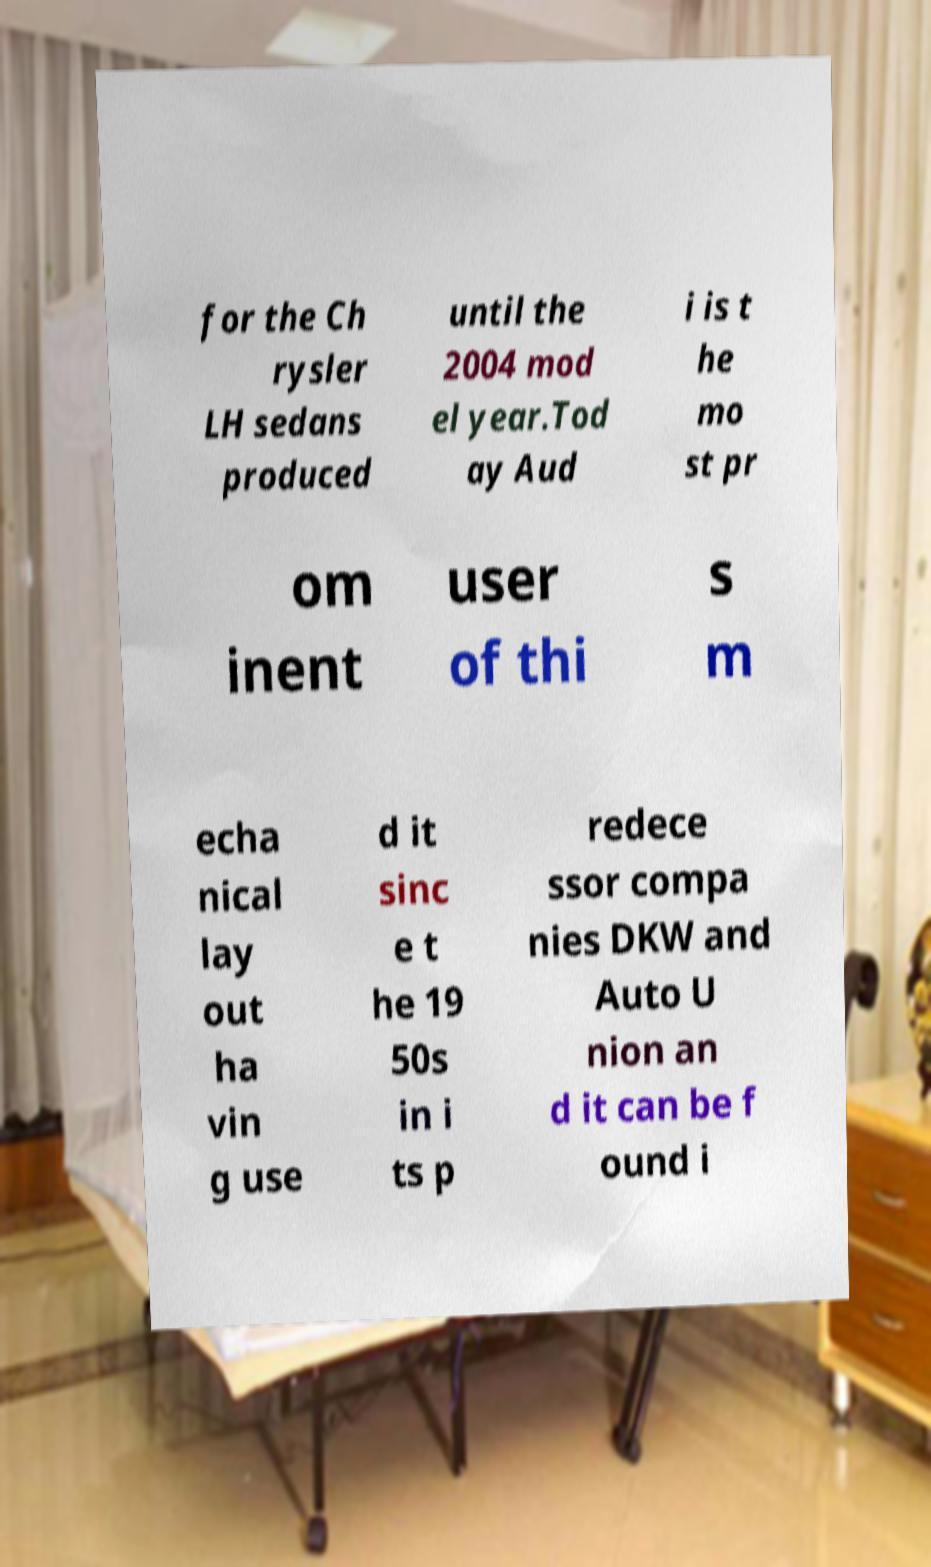I need the written content from this picture converted into text. Can you do that? for the Ch rysler LH sedans produced until the 2004 mod el year.Tod ay Aud i is t he mo st pr om inent user of thi s m echa nical lay out ha vin g use d it sinc e t he 19 50s in i ts p redece ssor compa nies DKW and Auto U nion an d it can be f ound i 